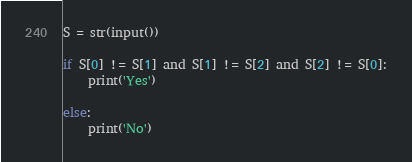<code> <loc_0><loc_0><loc_500><loc_500><_Python_>
S = str(input())

if S[0] != S[1] and S[1] != S[2] and S[2] != S[0]:
    print('Yes')

else:
    print('No')

</code> 